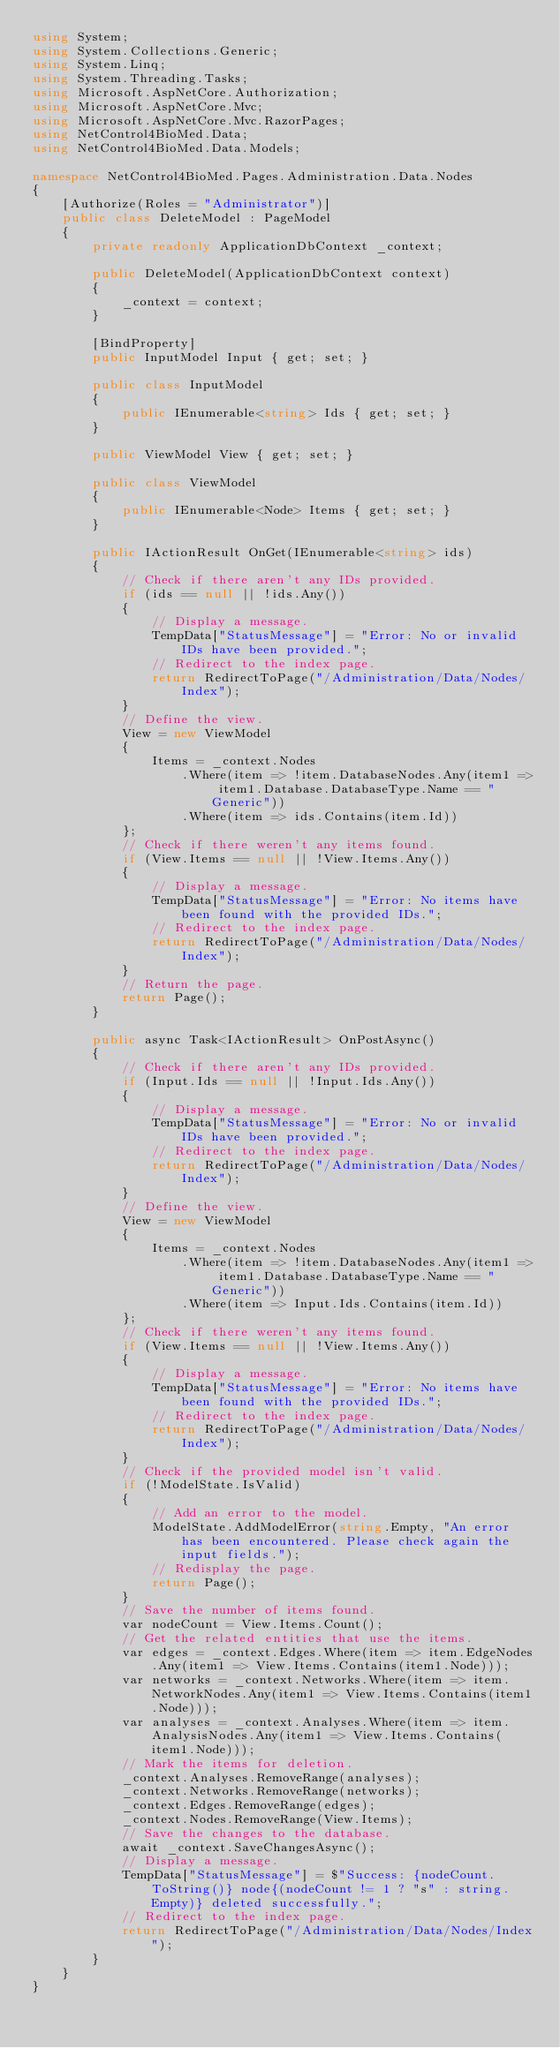Convert code to text. <code><loc_0><loc_0><loc_500><loc_500><_C#_>using System;
using System.Collections.Generic;
using System.Linq;
using System.Threading.Tasks;
using Microsoft.AspNetCore.Authorization;
using Microsoft.AspNetCore.Mvc;
using Microsoft.AspNetCore.Mvc.RazorPages;
using NetControl4BioMed.Data;
using NetControl4BioMed.Data.Models;

namespace NetControl4BioMed.Pages.Administration.Data.Nodes
{
    [Authorize(Roles = "Administrator")]
    public class DeleteModel : PageModel
    {
        private readonly ApplicationDbContext _context;

        public DeleteModel(ApplicationDbContext context)
        {
            _context = context;
        }

        [BindProperty]
        public InputModel Input { get; set; }

        public class InputModel
        {
            public IEnumerable<string> Ids { get; set; }
        }

        public ViewModel View { get; set; }

        public class ViewModel
        {
            public IEnumerable<Node> Items { get; set; }
        }

        public IActionResult OnGet(IEnumerable<string> ids)
        {
            // Check if there aren't any IDs provided.
            if (ids == null || !ids.Any())
            {
                // Display a message.
                TempData["StatusMessage"] = "Error: No or invalid IDs have been provided.";
                // Redirect to the index page.
                return RedirectToPage("/Administration/Data/Nodes/Index");
            }
            // Define the view.
            View = new ViewModel
            {
                Items = _context.Nodes
                    .Where(item => !item.DatabaseNodes.Any(item1 => item1.Database.DatabaseType.Name == "Generic"))
                    .Where(item => ids.Contains(item.Id))
            };
            // Check if there weren't any items found.
            if (View.Items == null || !View.Items.Any())
            {
                // Display a message.
                TempData["StatusMessage"] = "Error: No items have been found with the provided IDs.";
                // Redirect to the index page.
                return RedirectToPage("/Administration/Data/Nodes/Index");
            }
            // Return the page.
            return Page();
        }

        public async Task<IActionResult> OnPostAsync()
        {
            // Check if there aren't any IDs provided.
            if (Input.Ids == null || !Input.Ids.Any())
            {
                // Display a message.
                TempData["StatusMessage"] = "Error: No or invalid IDs have been provided.";
                // Redirect to the index page.
                return RedirectToPage("/Administration/Data/Nodes/Index");
            }
            // Define the view.
            View = new ViewModel
            {
                Items = _context.Nodes
                    .Where(item => !item.DatabaseNodes.Any(item1 => item1.Database.DatabaseType.Name == "Generic"))
                    .Where(item => Input.Ids.Contains(item.Id))
            };
            // Check if there weren't any items found.
            if (View.Items == null || !View.Items.Any())
            {
                // Display a message.
                TempData["StatusMessage"] = "Error: No items have been found with the provided IDs.";
                // Redirect to the index page.
                return RedirectToPage("/Administration/Data/Nodes/Index");
            }
            // Check if the provided model isn't valid.
            if (!ModelState.IsValid)
            {
                // Add an error to the model.
                ModelState.AddModelError(string.Empty, "An error has been encountered. Please check again the input fields.");
                // Redisplay the page.
                return Page();
            }
            // Save the number of items found.
            var nodeCount = View.Items.Count();
            // Get the related entities that use the items.
            var edges = _context.Edges.Where(item => item.EdgeNodes.Any(item1 => View.Items.Contains(item1.Node)));
            var networks = _context.Networks.Where(item => item.NetworkNodes.Any(item1 => View.Items.Contains(item1.Node)));
            var analyses = _context.Analyses.Where(item => item.AnalysisNodes.Any(item1 => View.Items.Contains(item1.Node)));
            // Mark the items for deletion.
            _context.Analyses.RemoveRange(analyses);
            _context.Networks.RemoveRange(networks);
            _context.Edges.RemoveRange(edges);
            _context.Nodes.RemoveRange(View.Items);
            // Save the changes to the database.
            await _context.SaveChangesAsync();
            // Display a message.
            TempData["StatusMessage"] = $"Success: {nodeCount.ToString()} node{(nodeCount != 1 ? "s" : string.Empty)} deleted successfully.";
            // Redirect to the index page.
            return RedirectToPage("/Administration/Data/Nodes/Index");
        }
    }
}
</code> 